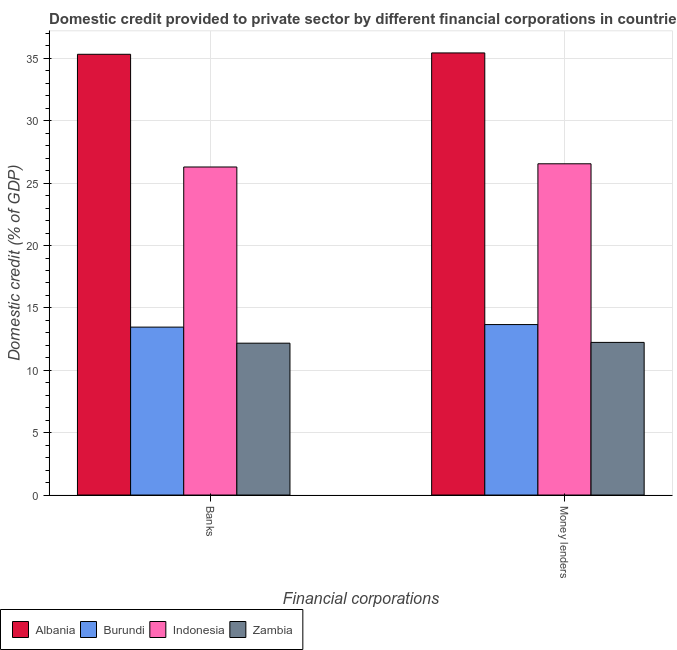How many different coloured bars are there?
Keep it short and to the point. 4. How many groups of bars are there?
Your response must be concise. 2. Are the number of bars per tick equal to the number of legend labels?
Your answer should be compact. Yes. Are the number of bars on each tick of the X-axis equal?
Provide a short and direct response. Yes. How many bars are there on the 1st tick from the right?
Your answer should be compact. 4. What is the label of the 2nd group of bars from the left?
Give a very brief answer. Money lenders. What is the domestic credit provided by money lenders in Albania?
Offer a very short reply. 35.44. Across all countries, what is the maximum domestic credit provided by money lenders?
Offer a very short reply. 35.44. Across all countries, what is the minimum domestic credit provided by banks?
Give a very brief answer. 12.17. In which country was the domestic credit provided by money lenders maximum?
Give a very brief answer. Albania. In which country was the domestic credit provided by money lenders minimum?
Keep it short and to the point. Zambia. What is the total domestic credit provided by money lenders in the graph?
Keep it short and to the point. 87.89. What is the difference between the domestic credit provided by banks in Indonesia and that in Zambia?
Your answer should be very brief. 14.12. What is the difference between the domestic credit provided by banks in Burundi and the domestic credit provided by money lenders in Zambia?
Provide a succinct answer. 1.22. What is the average domestic credit provided by banks per country?
Keep it short and to the point. 21.82. What is the difference between the domestic credit provided by banks and domestic credit provided by money lenders in Albania?
Provide a short and direct response. -0.11. In how many countries, is the domestic credit provided by banks greater than 12 %?
Make the answer very short. 4. What is the ratio of the domestic credit provided by money lenders in Albania to that in Indonesia?
Provide a short and direct response. 1.33. What does the 1st bar from the left in Banks represents?
Your answer should be compact. Albania. What does the 4th bar from the right in Money lenders represents?
Make the answer very short. Albania. How many countries are there in the graph?
Offer a terse response. 4. What is the difference between two consecutive major ticks on the Y-axis?
Your answer should be very brief. 5. Does the graph contain grids?
Keep it short and to the point. Yes. Where does the legend appear in the graph?
Keep it short and to the point. Bottom left. How many legend labels are there?
Ensure brevity in your answer.  4. How are the legend labels stacked?
Make the answer very short. Horizontal. What is the title of the graph?
Ensure brevity in your answer.  Domestic credit provided to private sector by different financial corporations in countries. What is the label or title of the X-axis?
Your answer should be very brief. Financial corporations. What is the label or title of the Y-axis?
Your answer should be compact. Domestic credit (% of GDP). What is the Domestic credit (% of GDP) in Albania in Banks?
Provide a short and direct response. 35.33. What is the Domestic credit (% of GDP) of Burundi in Banks?
Give a very brief answer. 13.46. What is the Domestic credit (% of GDP) of Indonesia in Banks?
Offer a very short reply. 26.3. What is the Domestic credit (% of GDP) in Zambia in Banks?
Give a very brief answer. 12.17. What is the Domestic credit (% of GDP) in Albania in Money lenders?
Ensure brevity in your answer.  35.44. What is the Domestic credit (% of GDP) in Burundi in Money lenders?
Your answer should be compact. 13.66. What is the Domestic credit (% of GDP) of Indonesia in Money lenders?
Make the answer very short. 26.55. What is the Domestic credit (% of GDP) of Zambia in Money lenders?
Your answer should be very brief. 12.24. Across all Financial corporations, what is the maximum Domestic credit (% of GDP) of Albania?
Provide a short and direct response. 35.44. Across all Financial corporations, what is the maximum Domestic credit (% of GDP) of Burundi?
Ensure brevity in your answer.  13.66. Across all Financial corporations, what is the maximum Domestic credit (% of GDP) in Indonesia?
Give a very brief answer. 26.55. Across all Financial corporations, what is the maximum Domestic credit (% of GDP) in Zambia?
Your answer should be compact. 12.24. Across all Financial corporations, what is the minimum Domestic credit (% of GDP) of Albania?
Your answer should be very brief. 35.33. Across all Financial corporations, what is the minimum Domestic credit (% of GDP) in Burundi?
Give a very brief answer. 13.46. Across all Financial corporations, what is the minimum Domestic credit (% of GDP) of Indonesia?
Ensure brevity in your answer.  26.3. Across all Financial corporations, what is the minimum Domestic credit (% of GDP) of Zambia?
Your answer should be compact. 12.17. What is the total Domestic credit (% of GDP) in Albania in the graph?
Give a very brief answer. 70.77. What is the total Domestic credit (% of GDP) of Burundi in the graph?
Offer a terse response. 27.13. What is the total Domestic credit (% of GDP) in Indonesia in the graph?
Give a very brief answer. 52.85. What is the total Domestic credit (% of GDP) in Zambia in the graph?
Your answer should be compact. 24.41. What is the difference between the Domestic credit (% of GDP) in Albania in Banks and that in Money lenders?
Keep it short and to the point. -0.11. What is the difference between the Domestic credit (% of GDP) in Burundi in Banks and that in Money lenders?
Offer a terse response. -0.2. What is the difference between the Domestic credit (% of GDP) of Indonesia in Banks and that in Money lenders?
Offer a terse response. -0.26. What is the difference between the Domestic credit (% of GDP) in Zambia in Banks and that in Money lenders?
Your answer should be compact. -0.06. What is the difference between the Domestic credit (% of GDP) in Albania in Banks and the Domestic credit (% of GDP) in Burundi in Money lenders?
Offer a terse response. 21.67. What is the difference between the Domestic credit (% of GDP) of Albania in Banks and the Domestic credit (% of GDP) of Indonesia in Money lenders?
Give a very brief answer. 8.78. What is the difference between the Domestic credit (% of GDP) in Albania in Banks and the Domestic credit (% of GDP) in Zambia in Money lenders?
Give a very brief answer. 23.09. What is the difference between the Domestic credit (% of GDP) of Burundi in Banks and the Domestic credit (% of GDP) of Indonesia in Money lenders?
Your response must be concise. -13.09. What is the difference between the Domestic credit (% of GDP) of Burundi in Banks and the Domestic credit (% of GDP) of Zambia in Money lenders?
Your response must be concise. 1.22. What is the difference between the Domestic credit (% of GDP) in Indonesia in Banks and the Domestic credit (% of GDP) in Zambia in Money lenders?
Ensure brevity in your answer.  14.06. What is the average Domestic credit (% of GDP) in Albania per Financial corporations?
Offer a terse response. 35.39. What is the average Domestic credit (% of GDP) in Burundi per Financial corporations?
Provide a succinct answer. 13.56. What is the average Domestic credit (% of GDP) in Indonesia per Financial corporations?
Give a very brief answer. 26.43. What is the average Domestic credit (% of GDP) of Zambia per Financial corporations?
Your response must be concise. 12.2. What is the difference between the Domestic credit (% of GDP) in Albania and Domestic credit (% of GDP) in Burundi in Banks?
Offer a very short reply. 21.87. What is the difference between the Domestic credit (% of GDP) of Albania and Domestic credit (% of GDP) of Indonesia in Banks?
Offer a very short reply. 9.03. What is the difference between the Domestic credit (% of GDP) in Albania and Domestic credit (% of GDP) in Zambia in Banks?
Your answer should be compact. 23.16. What is the difference between the Domestic credit (% of GDP) in Burundi and Domestic credit (% of GDP) in Indonesia in Banks?
Keep it short and to the point. -12.84. What is the difference between the Domestic credit (% of GDP) in Burundi and Domestic credit (% of GDP) in Zambia in Banks?
Give a very brief answer. 1.29. What is the difference between the Domestic credit (% of GDP) in Indonesia and Domestic credit (% of GDP) in Zambia in Banks?
Provide a succinct answer. 14.12. What is the difference between the Domestic credit (% of GDP) of Albania and Domestic credit (% of GDP) of Burundi in Money lenders?
Your answer should be compact. 21.78. What is the difference between the Domestic credit (% of GDP) in Albania and Domestic credit (% of GDP) in Indonesia in Money lenders?
Provide a short and direct response. 8.89. What is the difference between the Domestic credit (% of GDP) in Albania and Domestic credit (% of GDP) in Zambia in Money lenders?
Ensure brevity in your answer.  23.2. What is the difference between the Domestic credit (% of GDP) of Burundi and Domestic credit (% of GDP) of Indonesia in Money lenders?
Provide a short and direct response. -12.89. What is the difference between the Domestic credit (% of GDP) of Burundi and Domestic credit (% of GDP) of Zambia in Money lenders?
Your answer should be very brief. 1.43. What is the difference between the Domestic credit (% of GDP) of Indonesia and Domestic credit (% of GDP) of Zambia in Money lenders?
Offer a very short reply. 14.32. What is the ratio of the Domestic credit (% of GDP) of Burundi in Banks to that in Money lenders?
Keep it short and to the point. 0.99. What is the ratio of the Domestic credit (% of GDP) in Indonesia in Banks to that in Money lenders?
Your answer should be compact. 0.99. What is the ratio of the Domestic credit (% of GDP) of Zambia in Banks to that in Money lenders?
Ensure brevity in your answer.  0.99. What is the difference between the highest and the second highest Domestic credit (% of GDP) in Albania?
Offer a very short reply. 0.11. What is the difference between the highest and the second highest Domestic credit (% of GDP) of Burundi?
Offer a very short reply. 0.2. What is the difference between the highest and the second highest Domestic credit (% of GDP) in Indonesia?
Provide a short and direct response. 0.26. What is the difference between the highest and the second highest Domestic credit (% of GDP) in Zambia?
Give a very brief answer. 0.06. What is the difference between the highest and the lowest Domestic credit (% of GDP) of Albania?
Your answer should be very brief. 0.11. What is the difference between the highest and the lowest Domestic credit (% of GDP) of Burundi?
Your response must be concise. 0.2. What is the difference between the highest and the lowest Domestic credit (% of GDP) in Indonesia?
Your answer should be very brief. 0.26. What is the difference between the highest and the lowest Domestic credit (% of GDP) of Zambia?
Your response must be concise. 0.06. 